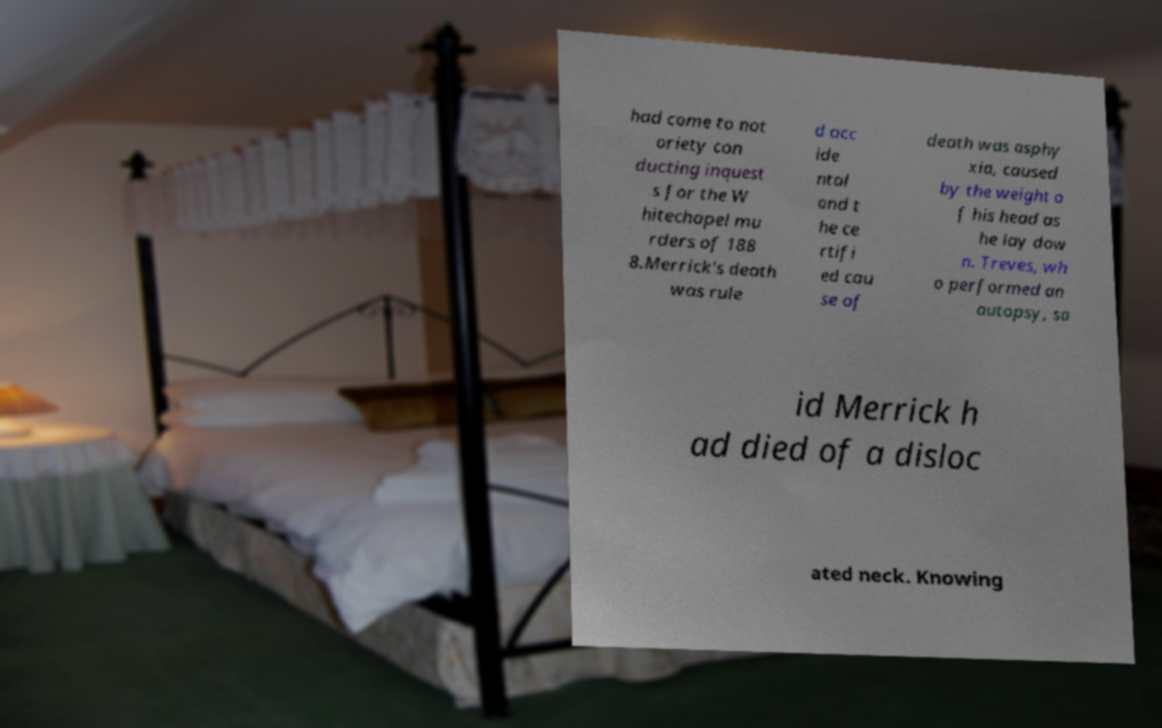Can you read and provide the text displayed in the image?This photo seems to have some interesting text. Can you extract and type it out for me? had come to not oriety con ducting inquest s for the W hitechapel mu rders of 188 8.Merrick's death was rule d acc ide ntal and t he ce rtifi ed cau se of death was asphy xia, caused by the weight o f his head as he lay dow n. Treves, wh o performed an autopsy, sa id Merrick h ad died of a disloc ated neck. Knowing 